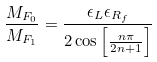<formula> <loc_0><loc_0><loc_500><loc_500>\frac { M _ { F _ { 0 } } } { M _ { F _ { 1 } } } = \frac { \epsilon _ { L } \epsilon _ { R _ { f } } } { 2 \cos \left [ \frac { n \pi } { 2 n + 1 } \right ] }</formula> 